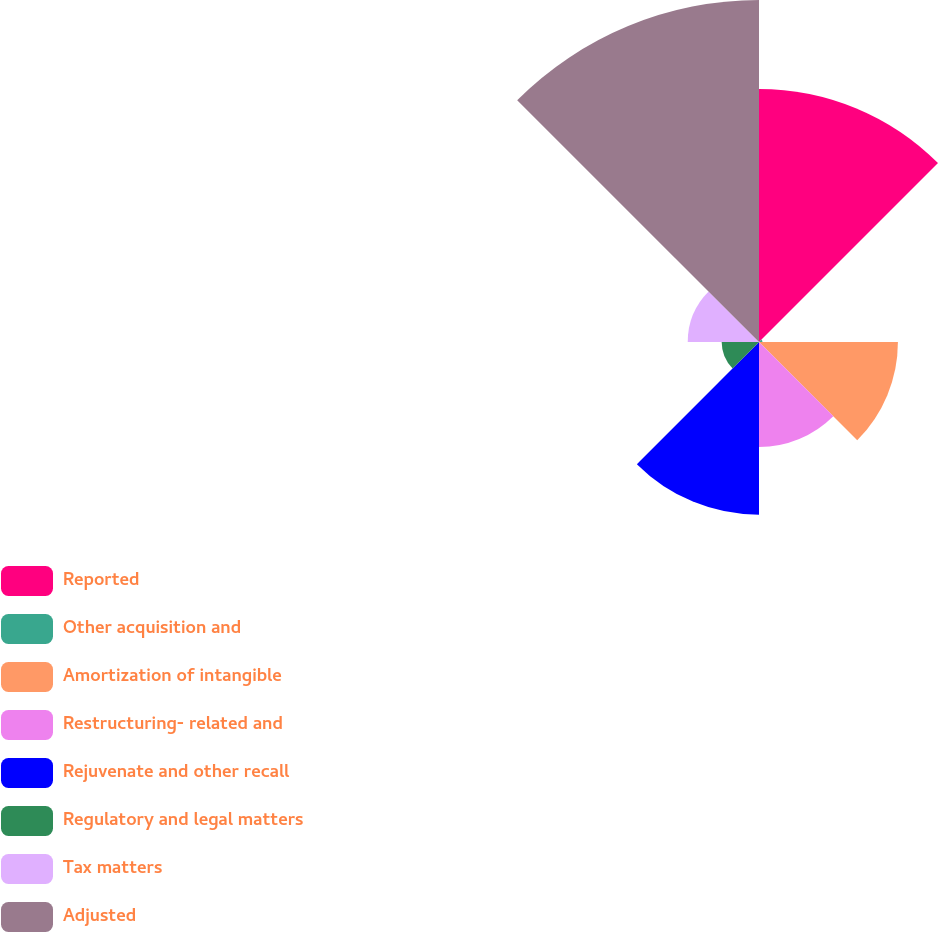Convert chart. <chart><loc_0><loc_0><loc_500><loc_500><pie_chart><fcel>Reported<fcel>Other acquisition and<fcel>Amortization of intangible<fcel>Restructuring- related and<fcel>Rejuvenate and other recall<fcel>Regulatory and legal matters<fcel>Tax matters<fcel>Adjusted<nl><fcel>22.52%<fcel>0.31%<fcel>12.36%<fcel>9.35%<fcel>15.37%<fcel>3.32%<fcel>6.34%<fcel>30.43%<nl></chart> 